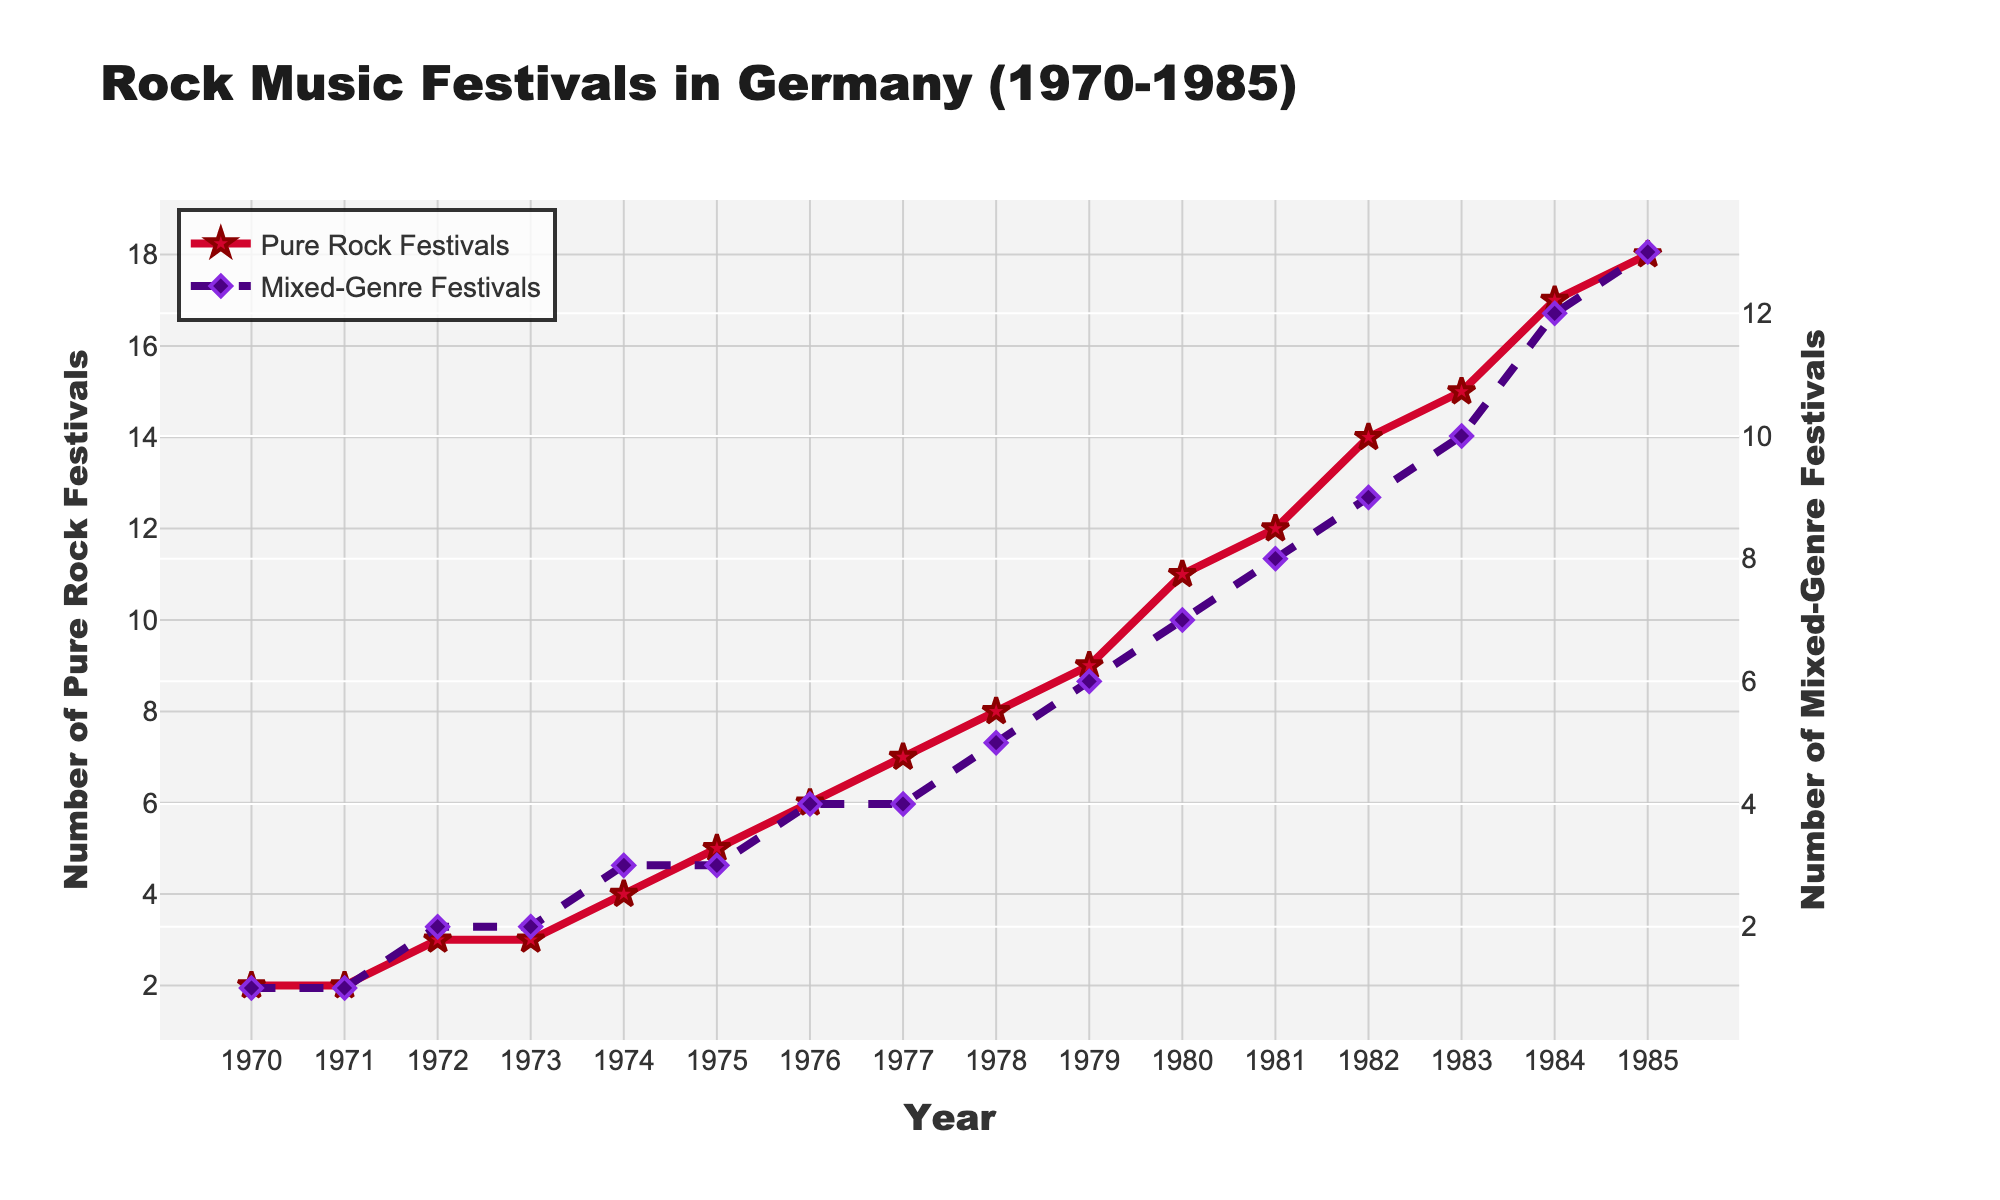What is the difference in the number of pure rock festivals between 1970 and 1985? In 1970, there were 2 pure rock festivals, and in 1985, there were 18. The difference can be calculated by subtracting the 1970 figure from the 1985 figure: 18 - 2.
Answer: 16 How many more pure rock festivals were there compared to mixed-genre festivals in 1983? In 1983, there were 15 pure rock festivals and 10 mixed-genre festivals. The difference is calculated as follows: 15 - 10.
Answer: 5 Which year saw the greatest increase in the number of pure rock festivals compared to the previous year? By calculating the yearly increase: 
1971-1970: 0, 
1972-1971: 1, 
1973-1972: 0, 
1974-1973: 1, 
1975-1974: 1, 
1976-1975: 1, 
1977-1976: 1, 
1978-1977: 1, 
1979-1978: 1, 
1980-1979: 2, 
1981-1980: 1, 
1982-1981: 2, 
1983-1982: 1, 
1984-1983: 2, 
1985-1984: 1, the greatest increase is between 1979 and 1980 with an increase of 2.
Answer: 1980 What was the average number of pure rock festivals per year between 1970 and 1985? The total number of pure rock festivals over these years is 138. Dividing by 16 (the number of years) gives the average: 138 / 16.
Answer: 8.625 In which year did mixed-genre festivals reach double the number compared to 1972? The number of mixed-genre festivals in 1972 was 2. Double this number is 4. Checking yearly data, in 1976, mixed-genre festivals reached 4.
Answer: 1976 Over the 15-year period shown, which category of festivals had a steadier increase in numbers, pure rock or mixed-genre? By visually inspecting the lines, the pure rock festival line shows more consistent yearly growth, while the mixed-genre line has a more variable pattern.
Answer: Pure rock festivals How many total festivals (pure rock and mixed-genre combined) were there in 1985? There were 18 pure rock festivals and 13 mixed-genre festivals in 1985. The total is calculated by adding these numbers: 18 + 13.
Answer: 31 